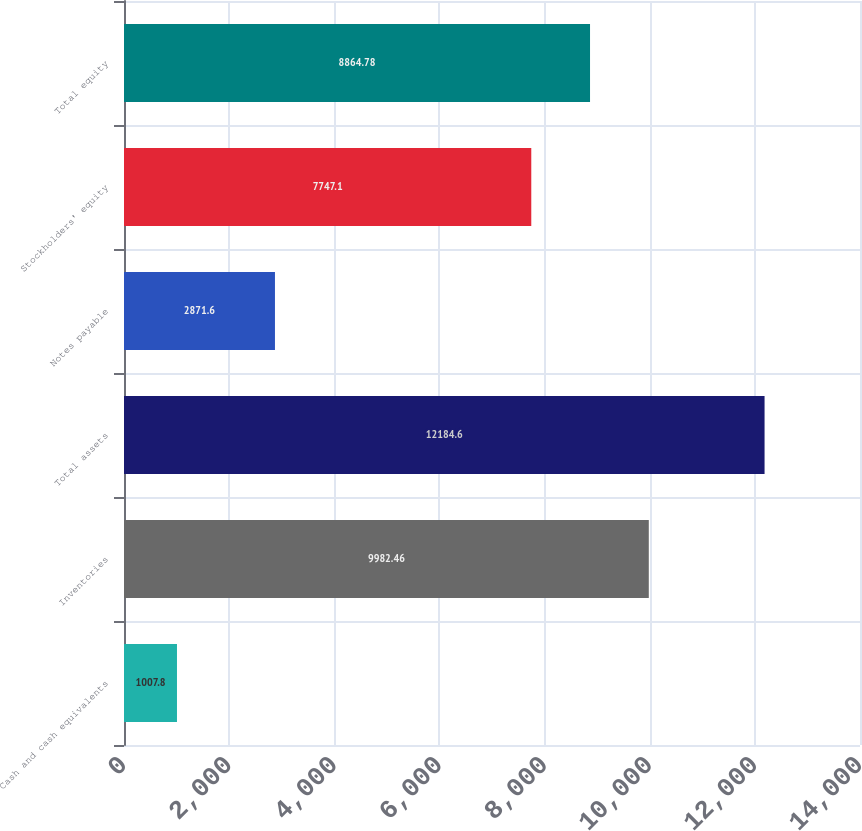Convert chart. <chart><loc_0><loc_0><loc_500><loc_500><bar_chart><fcel>Cash and cash equivalents<fcel>Inventories<fcel>Total assets<fcel>Notes payable<fcel>Stockholders' equity<fcel>Total equity<nl><fcel>1007.8<fcel>9982.46<fcel>12184.6<fcel>2871.6<fcel>7747.1<fcel>8864.78<nl></chart> 